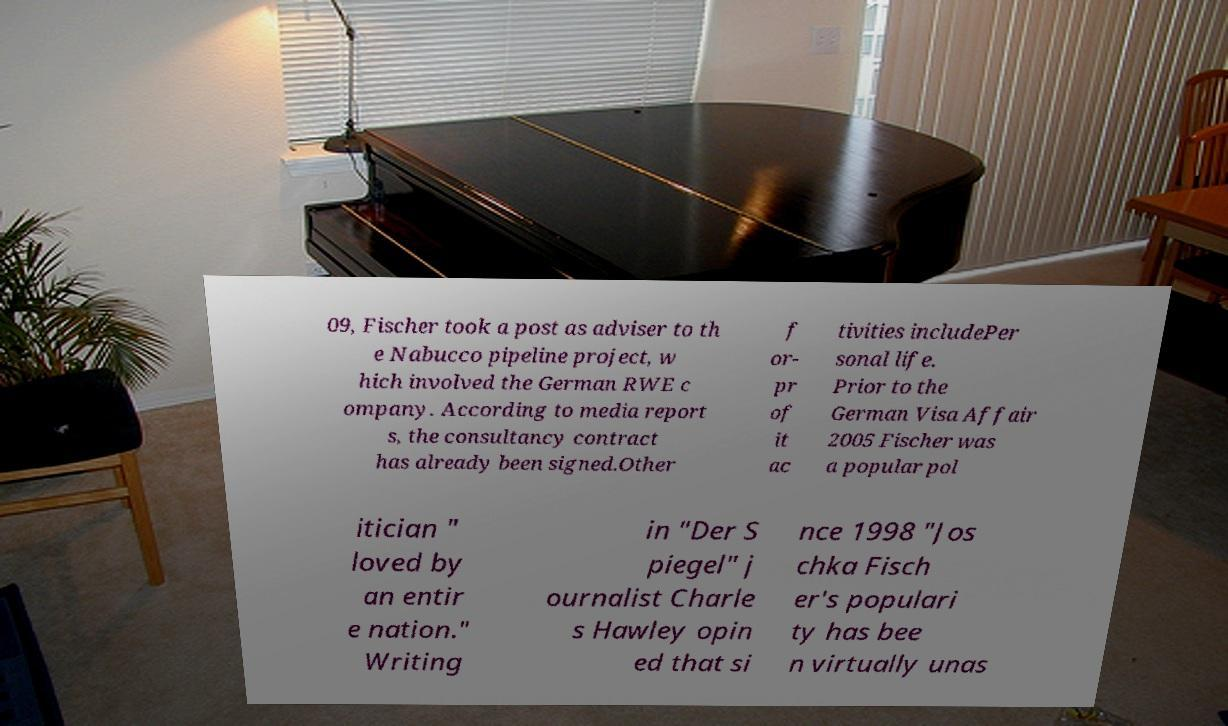Can you read and provide the text displayed in the image?This photo seems to have some interesting text. Can you extract and type it out for me? 09, Fischer took a post as adviser to th e Nabucco pipeline project, w hich involved the German RWE c ompany. According to media report s, the consultancy contract has already been signed.Other f or- pr of it ac tivities includePer sonal life. Prior to the German Visa Affair 2005 Fischer was a popular pol itician " loved by an entir e nation." Writing in "Der S piegel" j ournalist Charle s Hawley opin ed that si nce 1998 "Jos chka Fisch er's populari ty has bee n virtually unas 